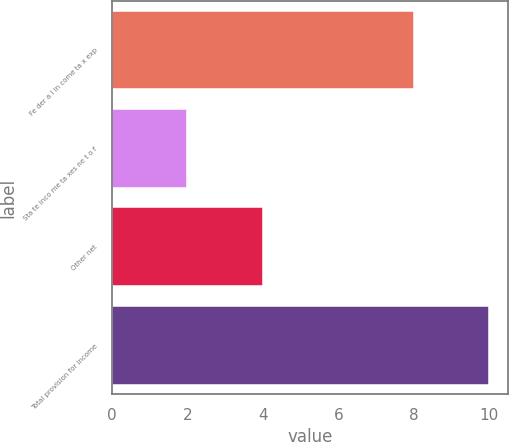Convert chart to OTSL. <chart><loc_0><loc_0><loc_500><loc_500><bar_chart><fcel>Fe der a l in come ta x exp<fcel>Sta te inco me ta xes ne t o f<fcel>Other net<fcel>Total provision for income<nl><fcel>8<fcel>2<fcel>4<fcel>10<nl></chart> 